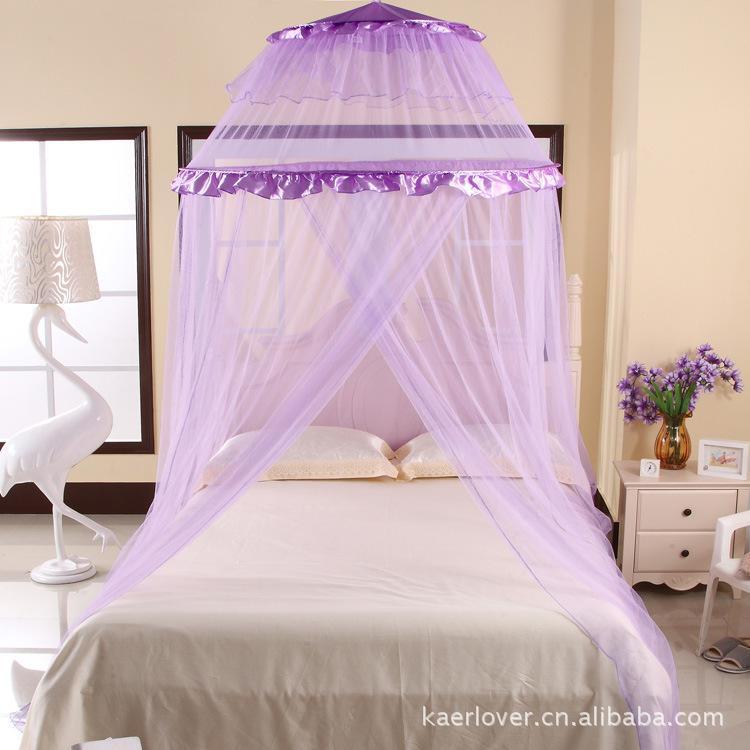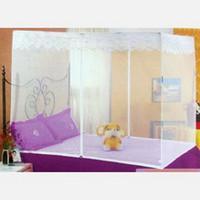The first image is the image on the left, the second image is the image on the right. Assess this claim about the two images: "Bright purple pillows sit on at least one of the beds.". Correct or not? Answer yes or no. Yes. The first image is the image on the left, the second image is the image on the right. Examine the images to the left and right. Is the description "One image shows a ceiling-suspended gauzy canopy over a bed." accurate? Answer yes or no. Yes. 